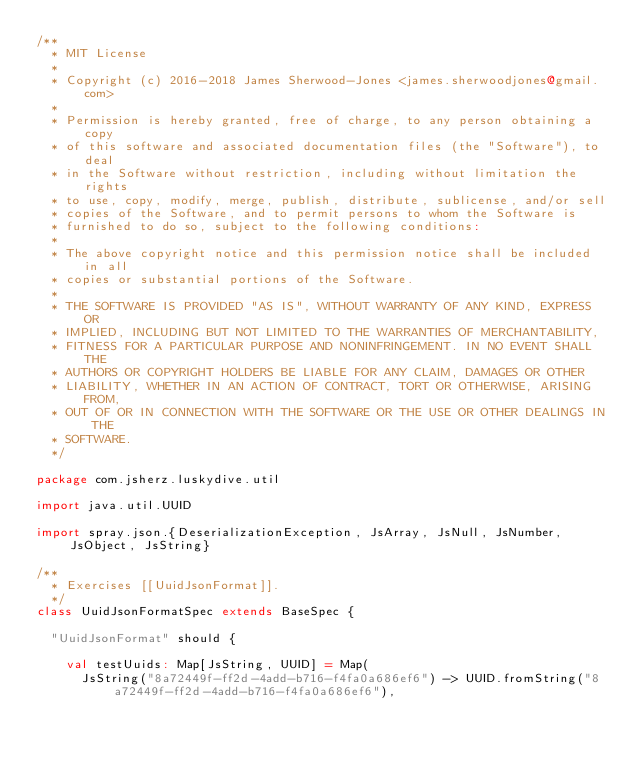Convert code to text. <code><loc_0><loc_0><loc_500><loc_500><_Scala_>/**
  * MIT License
  *
  * Copyright (c) 2016-2018 James Sherwood-Jones <james.sherwoodjones@gmail.com>
  *
  * Permission is hereby granted, free of charge, to any person obtaining a copy
  * of this software and associated documentation files (the "Software"), to deal
  * in the Software without restriction, including without limitation the rights
  * to use, copy, modify, merge, publish, distribute, sublicense, and/or sell
  * copies of the Software, and to permit persons to whom the Software is
  * furnished to do so, subject to the following conditions:
  *
  * The above copyright notice and this permission notice shall be included in all
  * copies or substantial portions of the Software.
  *
  * THE SOFTWARE IS PROVIDED "AS IS", WITHOUT WARRANTY OF ANY KIND, EXPRESS OR
  * IMPLIED, INCLUDING BUT NOT LIMITED TO THE WARRANTIES OF MERCHANTABILITY,
  * FITNESS FOR A PARTICULAR PURPOSE AND NONINFRINGEMENT. IN NO EVENT SHALL THE
  * AUTHORS OR COPYRIGHT HOLDERS BE LIABLE FOR ANY CLAIM, DAMAGES OR OTHER
  * LIABILITY, WHETHER IN AN ACTION OF CONTRACT, TORT OR OTHERWISE, ARISING FROM,
  * OUT OF OR IN CONNECTION WITH THE SOFTWARE OR THE USE OR OTHER DEALINGS IN THE
  * SOFTWARE.
  */

package com.jsherz.luskydive.util

import java.util.UUID

import spray.json.{DeserializationException, JsArray, JsNull, JsNumber, JsObject, JsString}

/**
  * Exercises [[UuidJsonFormat]].
  */
class UuidJsonFormatSpec extends BaseSpec {

  "UuidJsonFormat" should {

    val testUuids: Map[JsString, UUID] = Map(
      JsString("8a72449f-ff2d-4add-b716-f4fa0a686ef6") -> UUID.fromString("8a72449f-ff2d-4add-b716-f4fa0a686ef6"),</code> 